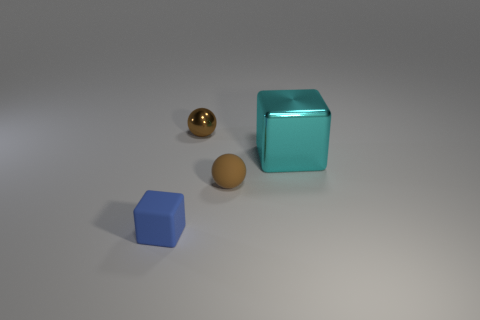What is the approximate ratio of sizes between the blue and the teal objects? It looks like the teal cube is approximately three to four times larger than the blue object in each dimension. 